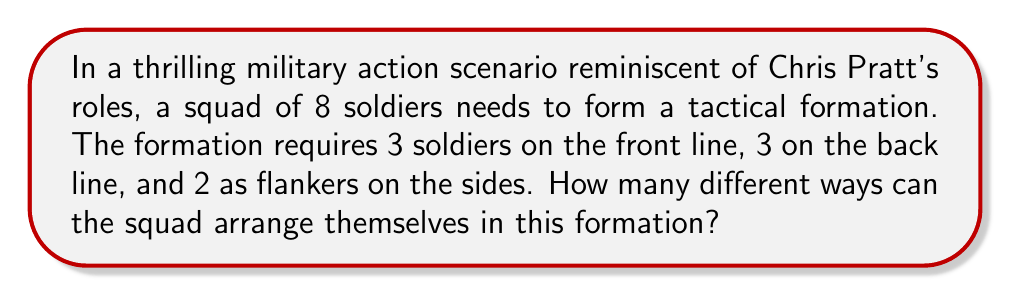Show me your answer to this math problem. Let's approach this step-by-step:

1) First, we need to choose 3 soldiers for the front line. This can be done in $\binom{8}{3}$ ways.

2) After the front line is chosen, we have 5 soldiers left. From these, we need to choose 3 for the back line. This can be done in $\binom{5}{3}$ ways.

3) The remaining 2 soldiers will automatically be the flankers.

4) By the multiplication principle, the total number of ways to arrange the squad is:

   $$\binom{8}{3} \cdot \binom{5}{3}$$

5) Let's calculate these combinations:

   $\binom{8}{3} = \frac{8!}{3!(8-3)!} = \frac{8!}{3!5!} = 56$

   $\binom{5}{3} = \frac{5!}{3!(5-3)!} = \frac{5!}{3!2!} = 10$

6) Therefore, the total number of formations is:

   $$56 \cdot 10 = 560$$
Answer: 560 